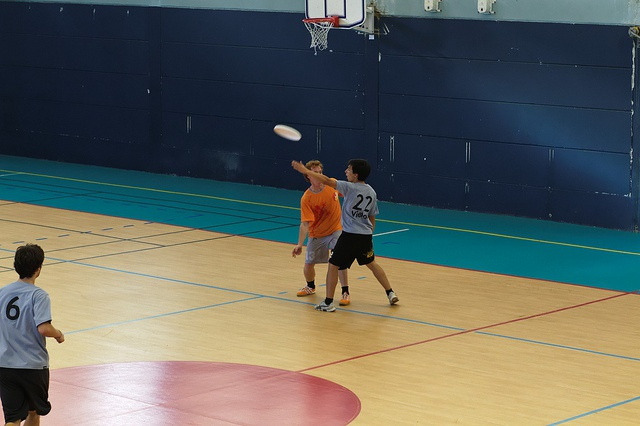Describe the objects in this image and their specific colors. I can see people in darkblue, black, gray, and darkgray tones, people in darkblue, black, gray, tan, and maroon tones, people in darkblue, brown, maroon, and gray tones, and frisbee in darkblue, darkgray, tan, and lightgray tones in this image. 